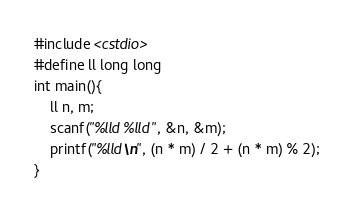Convert code to text. <code><loc_0><loc_0><loc_500><loc_500><_C++_>#include <cstdio>
#define ll long long
int main(){
	ll n, m;
	scanf("%lld %lld", &n, &m);
	printf("%lld\n", (n * m) / 2 + (n * m) % 2);
}</code> 